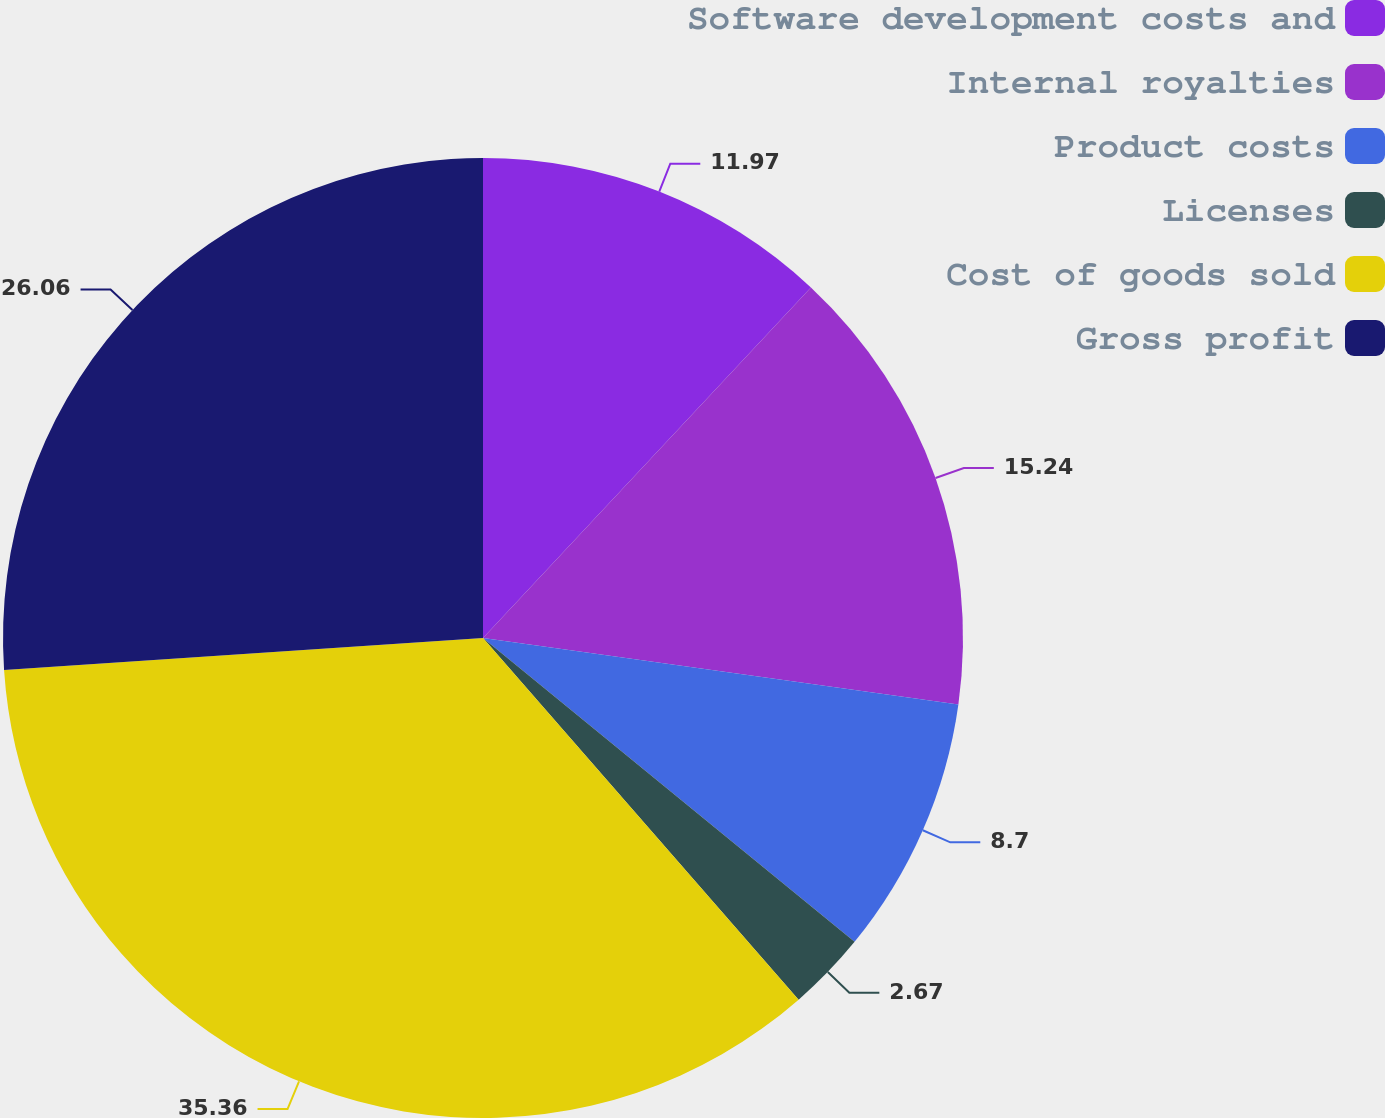<chart> <loc_0><loc_0><loc_500><loc_500><pie_chart><fcel>Software development costs and<fcel>Internal royalties<fcel>Product costs<fcel>Licenses<fcel>Cost of goods sold<fcel>Gross profit<nl><fcel>11.97%<fcel>15.24%<fcel>8.7%<fcel>2.67%<fcel>35.36%<fcel>26.06%<nl></chart> 